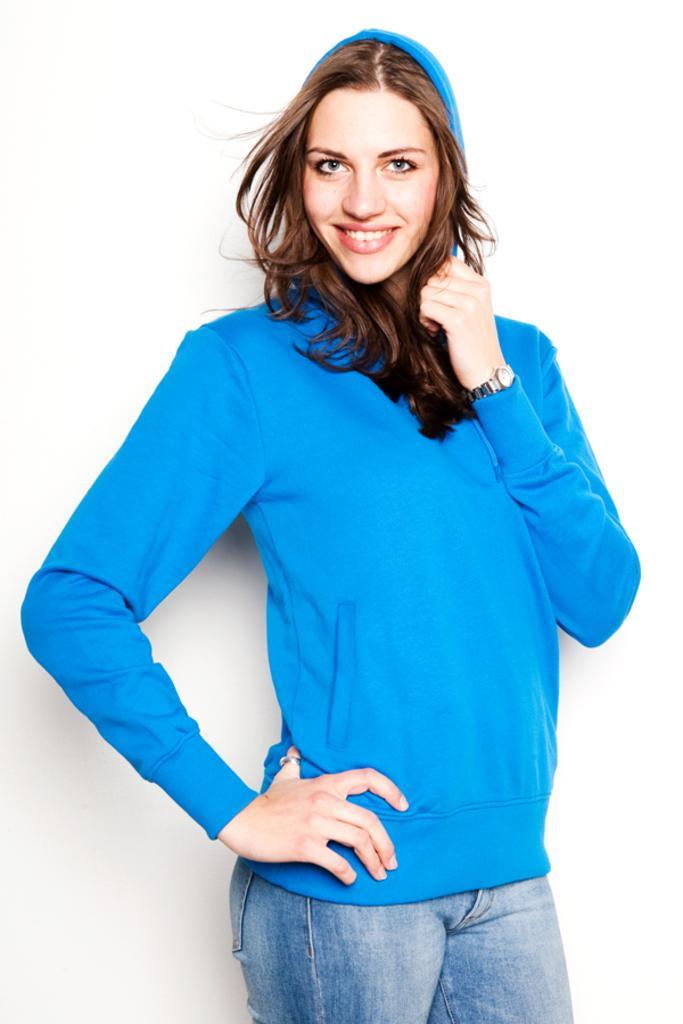Please provide a concise description of this image. In this picture we can see a woman wore a blue color sweater, watch and smiling and standing. 